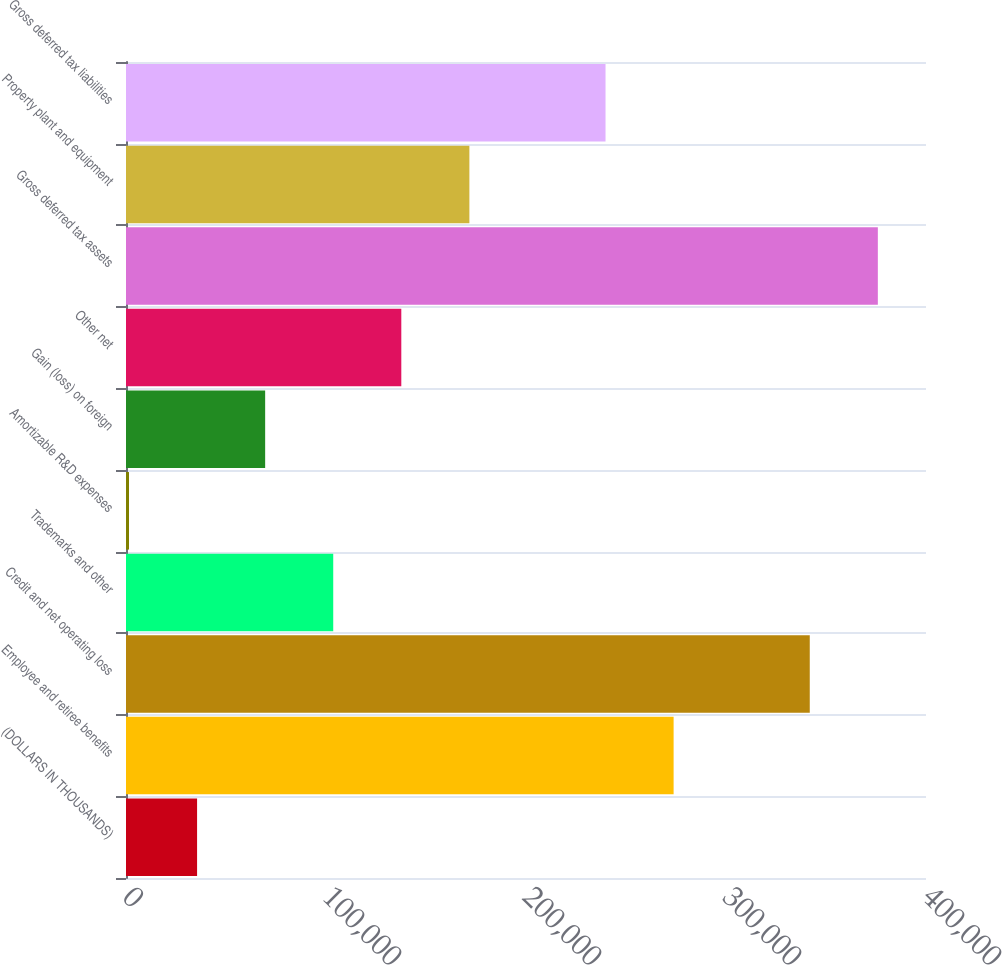Convert chart. <chart><loc_0><loc_0><loc_500><loc_500><bar_chart><fcel>(DOLLARS IN THOUSANDS)<fcel>Employee and retiree benefits<fcel>Credit and net operating loss<fcel>Trademarks and other<fcel>Amortizable R&D expenses<fcel>Gain (loss) on foreign<fcel>Other net<fcel>Gross deferred tax assets<fcel>Property plant and equipment<fcel>Gross deferred tax liabilities<nl><fcel>35539.9<fcel>273805<fcel>341881<fcel>103616<fcel>1502<fcel>69577.8<fcel>137654<fcel>375919<fcel>171692<fcel>239767<nl></chart> 